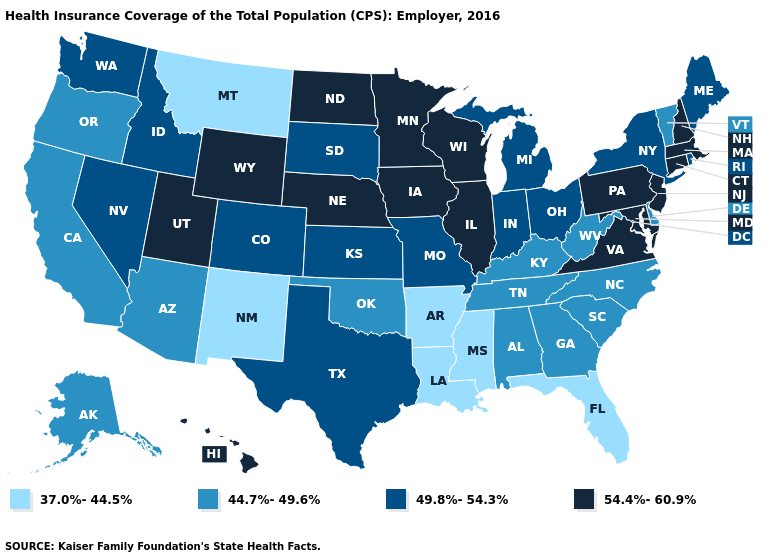What is the highest value in states that border Vermont?
Be succinct. 54.4%-60.9%. Among the states that border South Carolina , which have the lowest value?
Concise answer only. Georgia, North Carolina. Name the states that have a value in the range 37.0%-44.5%?
Short answer required. Arkansas, Florida, Louisiana, Mississippi, Montana, New Mexico. What is the lowest value in the USA?
Answer briefly. 37.0%-44.5%. Among the states that border Minnesota , which have the highest value?
Answer briefly. Iowa, North Dakota, Wisconsin. Among the states that border Michigan , does Wisconsin have the highest value?
Keep it brief. Yes. Name the states that have a value in the range 44.7%-49.6%?
Short answer required. Alabama, Alaska, Arizona, California, Delaware, Georgia, Kentucky, North Carolina, Oklahoma, Oregon, South Carolina, Tennessee, Vermont, West Virginia. How many symbols are there in the legend?
Be succinct. 4. Does Minnesota have the lowest value in the USA?
Answer briefly. No. What is the lowest value in the West?
Quick response, please. 37.0%-44.5%. Does the map have missing data?
Answer briefly. No. Does the first symbol in the legend represent the smallest category?
Answer briefly. Yes. Among the states that border New Mexico , does Colorado have the highest value?
Answer briefly. No. Name the states that have a value in the range 54.4%-60.9%?
Concise answer only. Connecticut, Hawaii, Illinois, Iowa, Maryland, Massachusetts, Minnesota, Nebraska, New Hampshire, New Jersey, North Dakota, Pennsylvania, Utah, Virginia, Wisconsin, Wyoming. Name the states that have a value in the range 49.8%-54.3%?
Write a very short answer. Colorado, Idaho, Indiana, Kansas, Maine, Michigan, Missouri, Nevada, New York, Ohio, Rhode Island, South Dakota, Texas, Washington. 